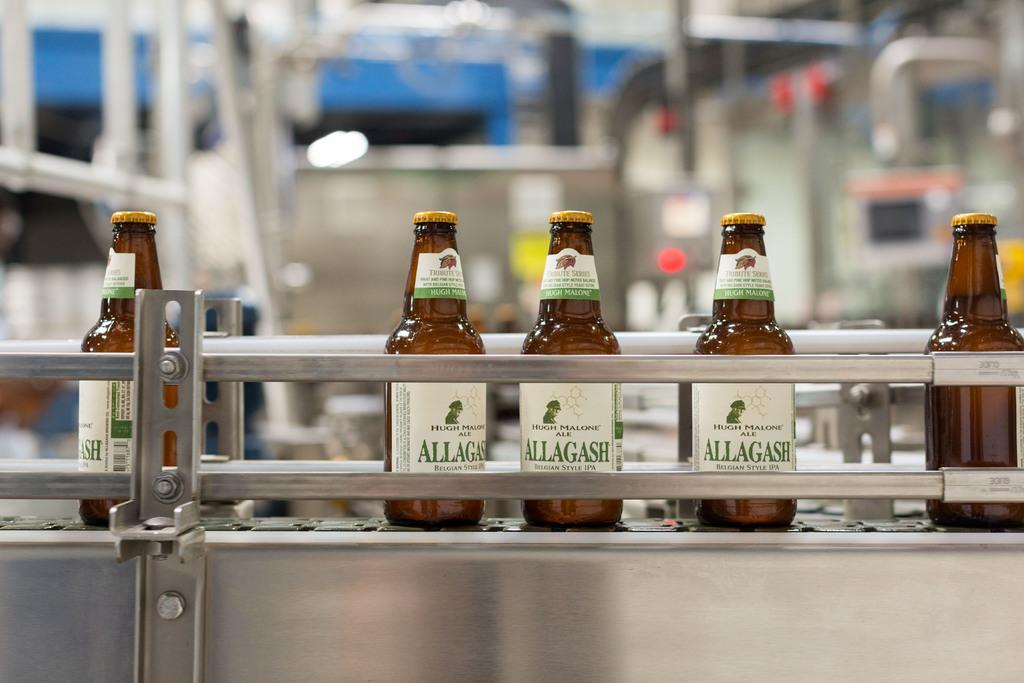<image>
Describe the image concisely. A beer production plant for Allagashe beer has a conveyor belt filled with bottled beer. 